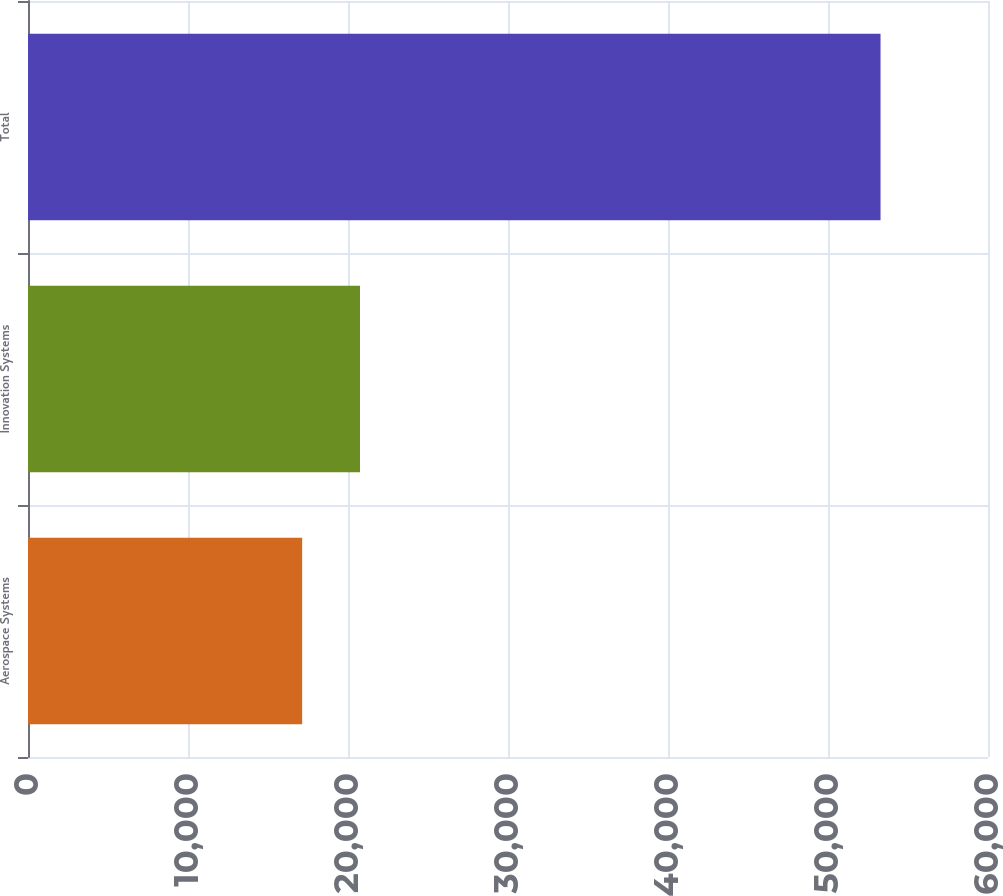Convert chart to OTSL. <chart><loc_0><loc_0><loc_500><loc_500><bar_chart><fcel>Aerospace Systems<fcel>Innovation Systems<fcel>Total<nl><fcel>17135<fcel>20749.8<fcel>53283<nl></chart> 